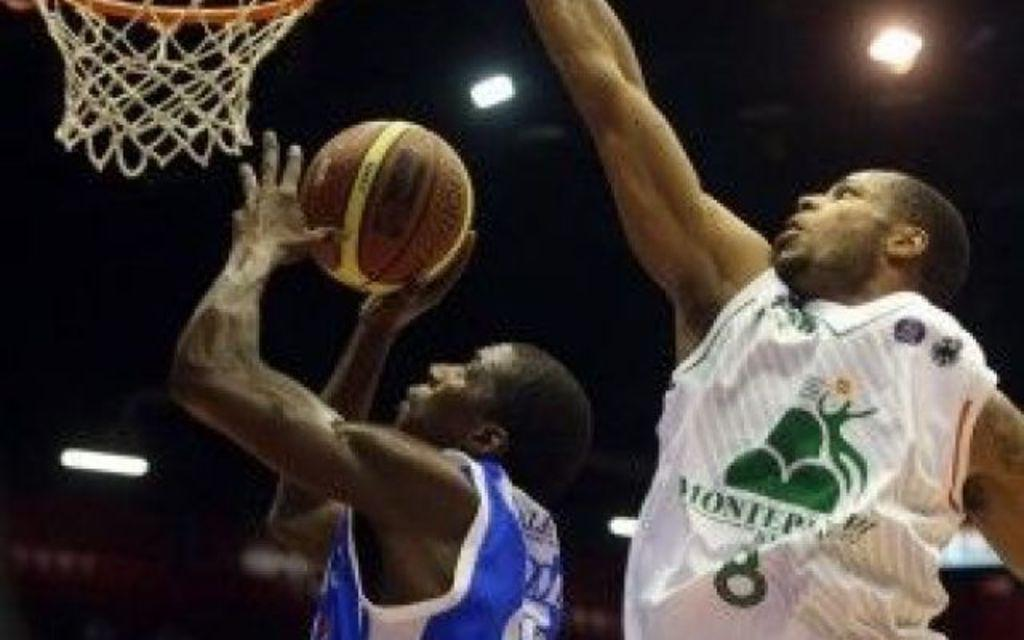How many people are in the image? There are two persons in the image. What is one person holding in the image? One person is holding a ball. What is located at the top of the image? There is a net at the top of the image. What can be seen in the image that provides illumination? There are some lights visible in the image. What is the name of the baby born to the person holding the ball in the image? There is no baby or birth event depicted in the image; it features two persons and a ball. What type of observation is being made by the person holding the ball in the image? There is no specific observation being made by the person holding the ball in the image; they are simply holding a ball. 